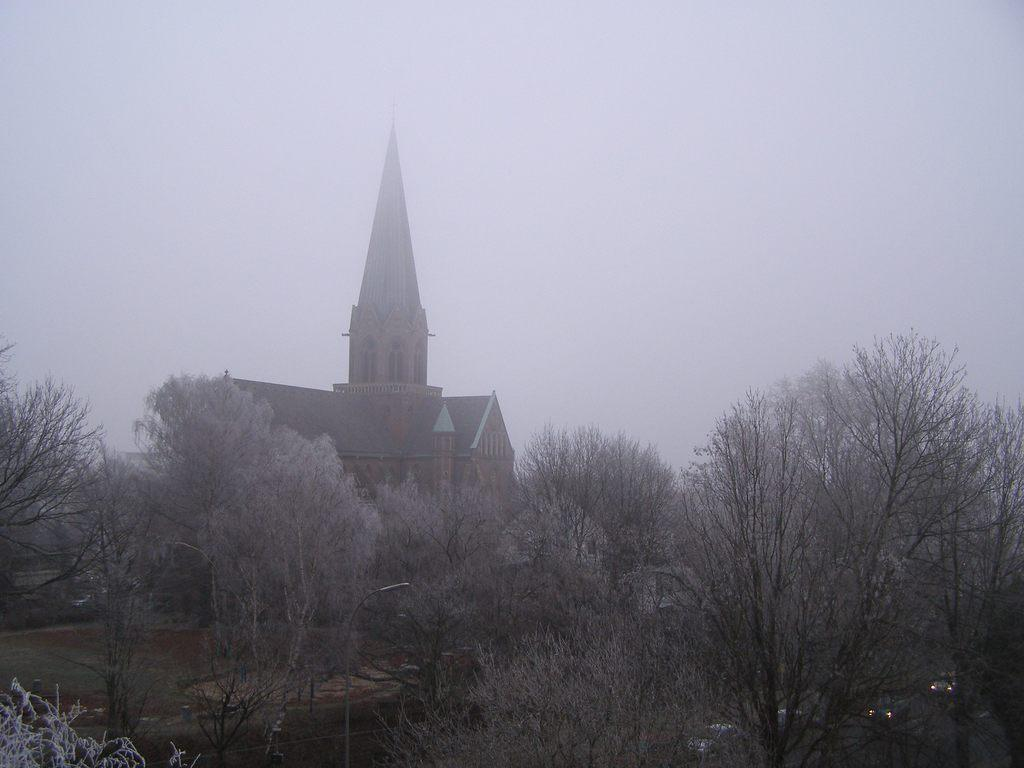What is the main structure in the middle of the image? There is a house in the middle of the image. What type of vegetation is present at the bottom of the image? There are trees at the bottom of the image. What is visible at the top of the image? The sky is visible at the top of the image. How would you describe the appearance of the sky in the image? The sky appears to be foggy in the image. Can you tell me how many women are visible in the image? There are no women present in the image. What type of screw can be seen holding the house together in the image? There are no screws visible in the image, and the house is not depicted as being held together by any visible fasteners. 